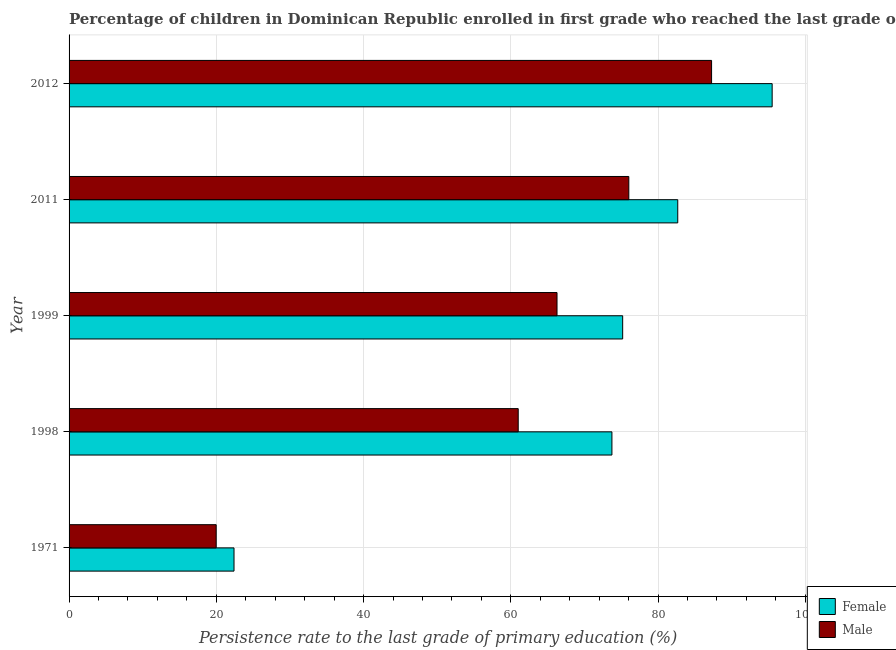How many different coloured bars are there?
Make the answer very short. 2. How many groups of bars are there?
Give a very brief answer. 5. What is the label of the 5th group of bars from the top?
Your answer should be very brief. 1971. What is the persistence rate of male students in 1998?
Keep it short and to the point. 61.01. Across all years, what is the maximum persistence rate of male students?
Ensure brevity in your answer.  87.27. Across all years, what is the minimum persistence rate of male students?
Keep it short and to the point. 19.98. What is the total persistence rate of male students in the graph?
Offer a terse response. 310.58. What is the difference between the persistence rate of male students in 1971 and that in 1998?
Your answer should be compact. -41.02. What is the difference between the persistence rate of female students in 1971 and the persistence rate of male students in 2012?
Offer a very short reply. -64.87. What is the average persistence rate of female students per year?
Offer a very short reply. 69.9. In the year 2012, what is the difference between the persistence rate of female students and persistence rate of male students?
Your answer should be compact. 8.23. What is the ratio of the persistence rate of female students in 2011 to that in 2012?
Give a very brief answer. 0.87. Is the difference between the persistence rate of female students in 1999 and 2012 greater than the difference between the persistence rate of male students in 1999 and 2012?
Provide a succinct answer. Yes. What is the difference between the highest and the second highest persistence rate of male students?
Ensure brevity in your answer.  11.24. What is the difference between the highest and the lowest persistence rate of female students?
Give a very brief answer. 73.1. In how many years, is the persistence rate of female students greater than the average persistence rate of female students taken over all years?
Ensure brevity in your answer.  4. Is the sum of the persistence rate of male students in 2011 and 2012 greater than the maximum persistence rate of female students across all years?
Provide a short and direct response. Yes. What does the 2nd bar from the top in 2012 represents?
Ensure brevity in your answer.  Female. Does the graph contain any zero values?
Provide a succinct answer. No. Does the graph contain grids?
Your answer should be very brief. Yes. How many legend labels are there?
Offer a terse response. 2. What is the title of the graph?
Your answer should be compact. Percentage of children in Dominican Republic enrolled in first grade who reached the last grade of primary education. What is the label or title of the X-axis?
Your answer should be compact. Persistence rate to the last grade of primary education (%). What is the label or title of the Y-axis?
Your answer should be compact. Year. What is the Persistence rate to the last grade of primary education (%) of Female in 1971?
Ensure brevity in your answer.  22.4. What is the Persistence rate to the last grade of primary education (%) of Male in 1971?
Provide a short and direct response. 19.98. What is the Persistence rate to the last grade of primary education (%) in Female in 1998?
Your answer should be compact. 73.74. What is the Persistence rate to the last grade of primary education (%) of Male in 1998?
Your response must be concise. 61.01. What is the Persistence rate to the last grade of primary education (%) in Female in 1999?
Your answer should be compact. 75.2. What is the Persistence rate to the last grade of primary education (%) in Male in 1999?
Ensure brevity in your answer.  66.28. What is the Persistence rate to the last grade of primary education (%) of Female in 2011?
Ensure brevity in your answer.  82.68. What is the Persistence rate to the last grade of primary education (%) in Male in 2011?
Provide a short and direct response. 76.03. What is the Persistence rate to the last grade of primary education (%) of Female in 2012?
Make the answer very short. 95.5. What is the Persistence rate to the last grade of primary education (%) in Male in 2012?
Keep it short and to the point. 87.27. Across all years, what is the maximum Persistence rate to the last grade of primary education (%) in Female?
Make the answer very short. 95.5. Across all years, what is the maximum Persistence rate to the last grade of primary education (%) of Male?
Your response must be concise. 87.27. Across all years, what is the minimum Persistence rate to the last grade of primary education (%) of Female?
Provide a short and direct response. 22.4. Across all years, what is the minimum Persistence rate to the last grade of primary education (%) of Male?
Provide a short and direct response. 19.98. What is the total Persistence rate to the last grade of primary education (%) of Female in the graph?
Ensure brevity in your answer.  349.51. What is the total Persistence rate to the last grade of primary education (%) of Male in the graph?
Your answer should be compact. 310.58. What is the difference between the Persistence rate to the last grade of primary education (%) of Female in 1971 and that in 1998?
Provide a short and direct response. -51.33. What is the difference between the Persistence rate to the last grade of primary education (%) of Male in 1971 and that in 1998?
Make the answer very short. -41.03. What is the difference between the Persistence rate to the last grade of primary education (%) in Female in 1971 and that in 1999?
Provide a short and direct response. -52.79. What is the difference between the Persistence rate to the last grade of primary education (%) in Male in 1971 and that in 1999?
Your answer should be very brief. -46.3. What is the difference between the Persistence rate to the last grade of primary education (%) in Female in 1971 and that in 2011?
Your answer should be very brief. -60.27. What is the difference between the Persistence rate to the last grade of primary education (%) in Male in 1971 and that in 2011?
Ensure brevity in your answer.  -56.05. What is the difference between the Persistence rate to the last grade of primary education (%) in Female in 1971 and that in 2012?
Keep it short and to the point. -73.1. What is the difference between the Persistence rate to the last grade of primary education (%) of Male in 1971 and that in 2012?
Ensure brevity in your answer.  -67.29. What is the difference between the Persistence rate to the last grade of primary education (%) of Female in 1998 and that in 1999?
Give a very brief answer. -1.46. What is the difference between the Persistence rate to the last grade of primary education (%) of Male in 1998 and that in 1999?
Ensure brevity in your answer.  -5.27. What is the difference between the Persistence rate to the last grade of primary education (%) of Female in 1998 and that in 2011?
Ensure brevity in your answer.  -8.94. What is the difference between the Persistence rate to the last grade of primary education (%) in Male in 1998 and that in 2011?
Your answer should be very brief. -15.02. What is the difference between the Persistence rate to the last grade of primary education (%) in Female in 1998 and that in 2012?
Your answer should be compact. -21.76. What is the difference between the Persistence rate to the last grade of primary education (%) in Male in 1998 and that in 2012?
Give a very brief answer. -26.26. What is the difference between the Persistence rate to the last grade of primary education (%) in Female in 1999 and that in 2011?
Give a very brief answer. -7.48. What is the difference between the Persistence rate to the last grade of primary education (%) in Male in 1999 and that in 2011?
Provide a succinct answer. -9.75. What is the difference between the Persistence rate to the last grade of primary education (%) in Female in 1999 and that in 2012?
Offer a terse response. -20.3. What is the difference between the Persistence rate to the last grade of primary education (%) of Male in 1999 and that in 2012?
Make the answer very short. -20.99. What is the difference between the Persistence rate to the last grade of primary education (%) of Female in 2011 and that in 2012?
Offer a terse response. -12.82. What is the difference between the Persistence rate to the last grade of primary education (%) of Male in 2011 and that in 2012?
Ensure brevity in your answer.  -11.24. What is the difference between the Persistence rate to the last grade of primary education (%) in Female in 1971 and the Persistence rate to the last grade of primary education (%) in Male in 1998?
Make the answer very short. -38.6. What is the difference between the Persistence rate to the last grade of primary education (%) of Female in 1971 and the Persistence rate to the last grade of primary education (%) of Male in 1999?
Make the answer very short. -43.87. What is the difference between the Persistence rate to the last grade of primary education (%) in Female in 1971 and the Persistence rate to the last grade of primary education (%) in Male in 2011?
Offer a terse response. -53.63. What is the difference between the Persistence rate to the last grade of primary education (%) in Female in 1971 and the Persistence rate to the last grade of primary education (%) in Male in 2012?
Keep it short and to the point. -64.87. What is the difference between the Persistence rate to the last grade of primary education (%) of Female in 1998 and the Persistence rate to the last grade of primary education (%) of Male in 1999?
Offer a terse response. 7.46. What is the difference between the Persistence rate to the last grade of primary education (%) in Female in 1998 and the Persistence rate to the last grade of primary education (%) in Male in 2011?
Provide a short and direct response. -2.29. What is the difference between the Persistence rate to the last grade of primary education (%) in Female in 1998 and the Persistence rate to the last grade of primary education (%) in Male in 2012?
Provide a short and direct response. -13.54. What is the difference between the Persistence rate to the last grade of primary education (%) of Female in 1999 and the Persistence rate to the last grade of primary education (%) of Male in 2011?
Provide a short and direct response. -0.84. What is the difference between the Persistence rate to the last grade of primary education (%) in Female in 1999 and the Persistence rate to the last grade of primary education (%) in Male in 2012?
Provide a succinct answer. -12.08. What is the difference between the Persistence rate to the last grade of primary education (%) of Female in 2011 and the Persistence rate to the last grade of primary education (%) of Male in 2012?
Give a very brief answer. -4.59. What is the average Persistence rate to the last grade of primary education (%) of Female per year?
Your answer should be very brief. 69.9. What is the average Persistence rate to the last grade of primary education (%) in Male per year?
Your answer should be very brief. 62.12. In the year 1971, what is the difference between the Persistence rate to the last grade of primary education (%) in Female and Persistence rate to the last grade of primary education (%) in Male?
Offer a very short reply. 2.42. In the year 1998, what is the difference between the Persistence rate to the last grade of primary education (%) of Female and Persistence rate to the last grade of primary education (%) of Male?
Your answer should be compact. 12.73. In the year 1999, what is the difference between the Persistence rate to the last grade of primary education (%) of Female and Persistence rate to the last grade of primary education (%) of Male?
Your answer should be compact. 8.92. In the year 2011, what is the difference between the Persistence rate to the last grade of primary education (%) in Female and Persistence rate to the last grade of primary education (%) in Male?
Your answer should be very brief. 6.65. In the year 2012, what is the difference between the Persistence rate to the last grade of primary education (%) of Female and Persistence rate to the last grade of primary education (%) of Male?
Offer a terse response. 8.23. What is the ratio of the Persistence rate to the last grade of primary education (%) in Female in 1971 to that in 1998?
Provide a succinct answer. 0.3. What is the ratio of the Persistence rate to the last grade of primary education (%) in Male in 1971 to that in 1998?
Ensure brevity in your answer.  0.33. What is the ratio of the Persistence rate to the last grade of primary education (%) in Female in 1971 to that in 1999?
Provide a short and direct response. 0.3. What is the ratio of the Persistence rate to the last grade of primary education (%) in Male in 1971 to that in 1999?
Your answer should be compact. 0.3. What is the ratio of the Persistence rate to the last grade of primary education (%) in Female in 1971 to that in 2011?
Your answer should be very brief. 0.27. What is the ratio of the Persistence rate to the last grade of primary education (%) of Male in 1971 to that in 2011?
Provide a short and direct response. 0.26. What is the ratio of the Persistence rate to the last grade of primary education (%) in Female in 1971 to that in 2012?
Your answer should be compact. 0.23. What is the ratio of the Persistence rate to the last grade of primary education (%) of Male in 1971 to that in 2012?
Your response must be concise. 0.23. What is the ratio of the Persistence rate to the last grade of primary education (%) in Female in 1998 to that in 1999?
Your response must be concise. 0.98. What is the ratio of the Persistence rate to the last grade of primary education (%) of Male in 1998 to that in 1999?
Provide a short and direct response. 0.92. What is the ratio of the Persistence rate to the last grade of primary education (%) in Female in 1998 to that in 2011?
Make the answer very short. 0.89. What is the ratio of the Persistence rate to the last grade of primary education (%) in Male in 1998 to that in 2011?
Keep it short and to the point. 0.8. What is the ratio of the Persistence rate to the last grade of primary education (%) in Female in 1998 to that in 2012?
Your answer should be very brief. 0.77. What is the ratio of the Persistence rate to the last grade of primary education (%) of Male in 1998 to that in 2012?
Offer a very short reply. 0.7. What is the ratio of the Persistence rate to the last grade of primary education (%) of Female in 1999 to that in 2011?
Provide a succinct answer. 0.91. What is the ratio of the Persistence rate to the last grade of primary education (%) of Male in 1999 to that in 2011?
Your answer should be very brief. 0.87. What is the ratio of the Persistence rate to the last grade of primary education (%) in Female in 1999 to that in 2012?
Ensure brevity in your answer.  0.79. What is the ratio of the Persistence rate to the last grade of primary education (%) of Male in 1999 to that in 2012?
Make the answer very short. 0.76. What is the ratio of the Persistence rate to the last grade of primary education (%) in Female in 2011 to that in 2012?
Make the answer very short. 0.87. What is the ratio of the Persistence rate to the last grade of primary education (%) in Male in 2011 to that in 2012?
Provide a short and direct response. 0.87. What is the difference between the highest and the second highest Persistence rate to the last grade of primary education (%) of Female?
Ensure brevity in your answer.  12.82. What is the difference between the highest and the second highest Persistence rate to the last grade of primary education (%) of Male?
Your answer should be compact. 11.24. What is the difference between the highest and the lowest Persistence rate to the last grade of primary education (%) in Female?
Provide a short and direct response. 73.1. What is the difference between the highest and the lowest Persistence rate to the last grade of primary education (%) of Male?
Provide a succinct answer. 67.29. 